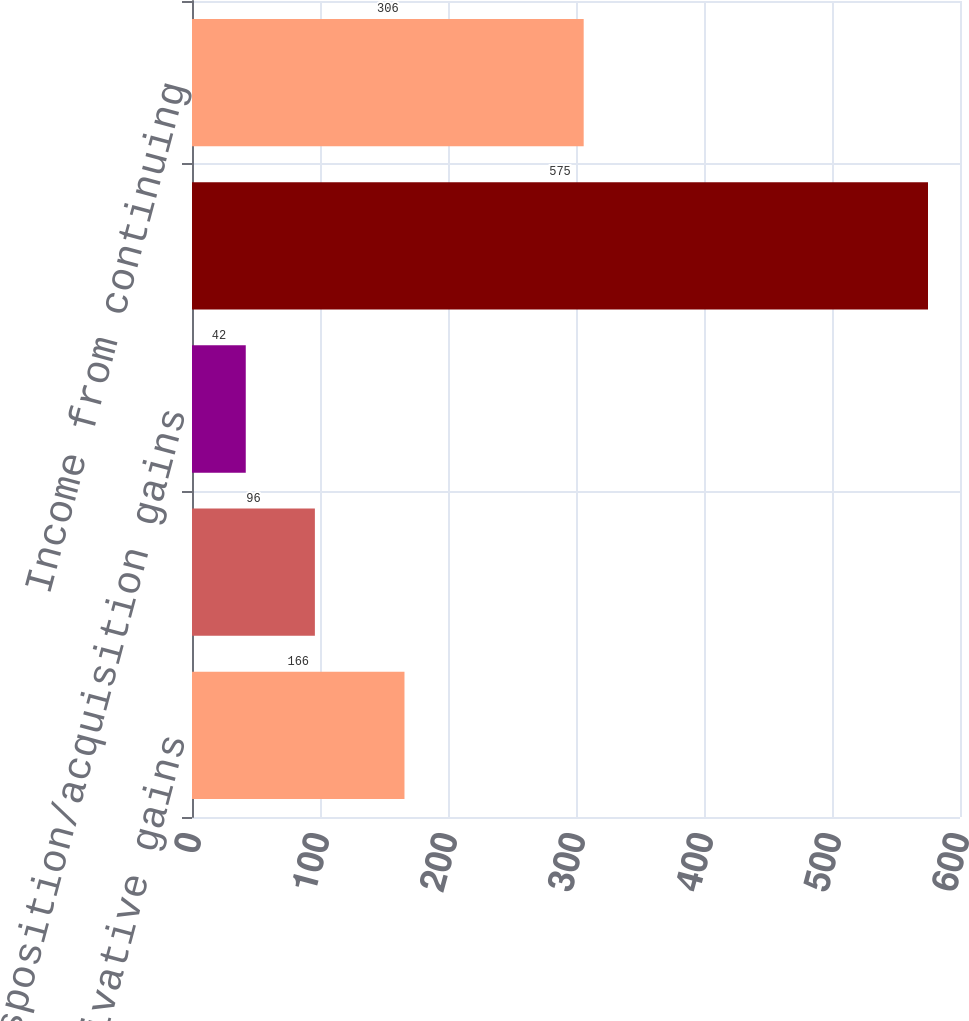<chart> <loc_0><loc_0><loc_500><loc_500><bar_chart><fcel>Unrealized derivative gains<fcel>Unrealized foreign currency<fcel>Disposition/acquisition gains<fcel>Pre-tax contribution<fcel>Income from continuing<nl><fcel>166<fcel>96<fcel>42<fcel>575<fcel>306<nl></chart> 